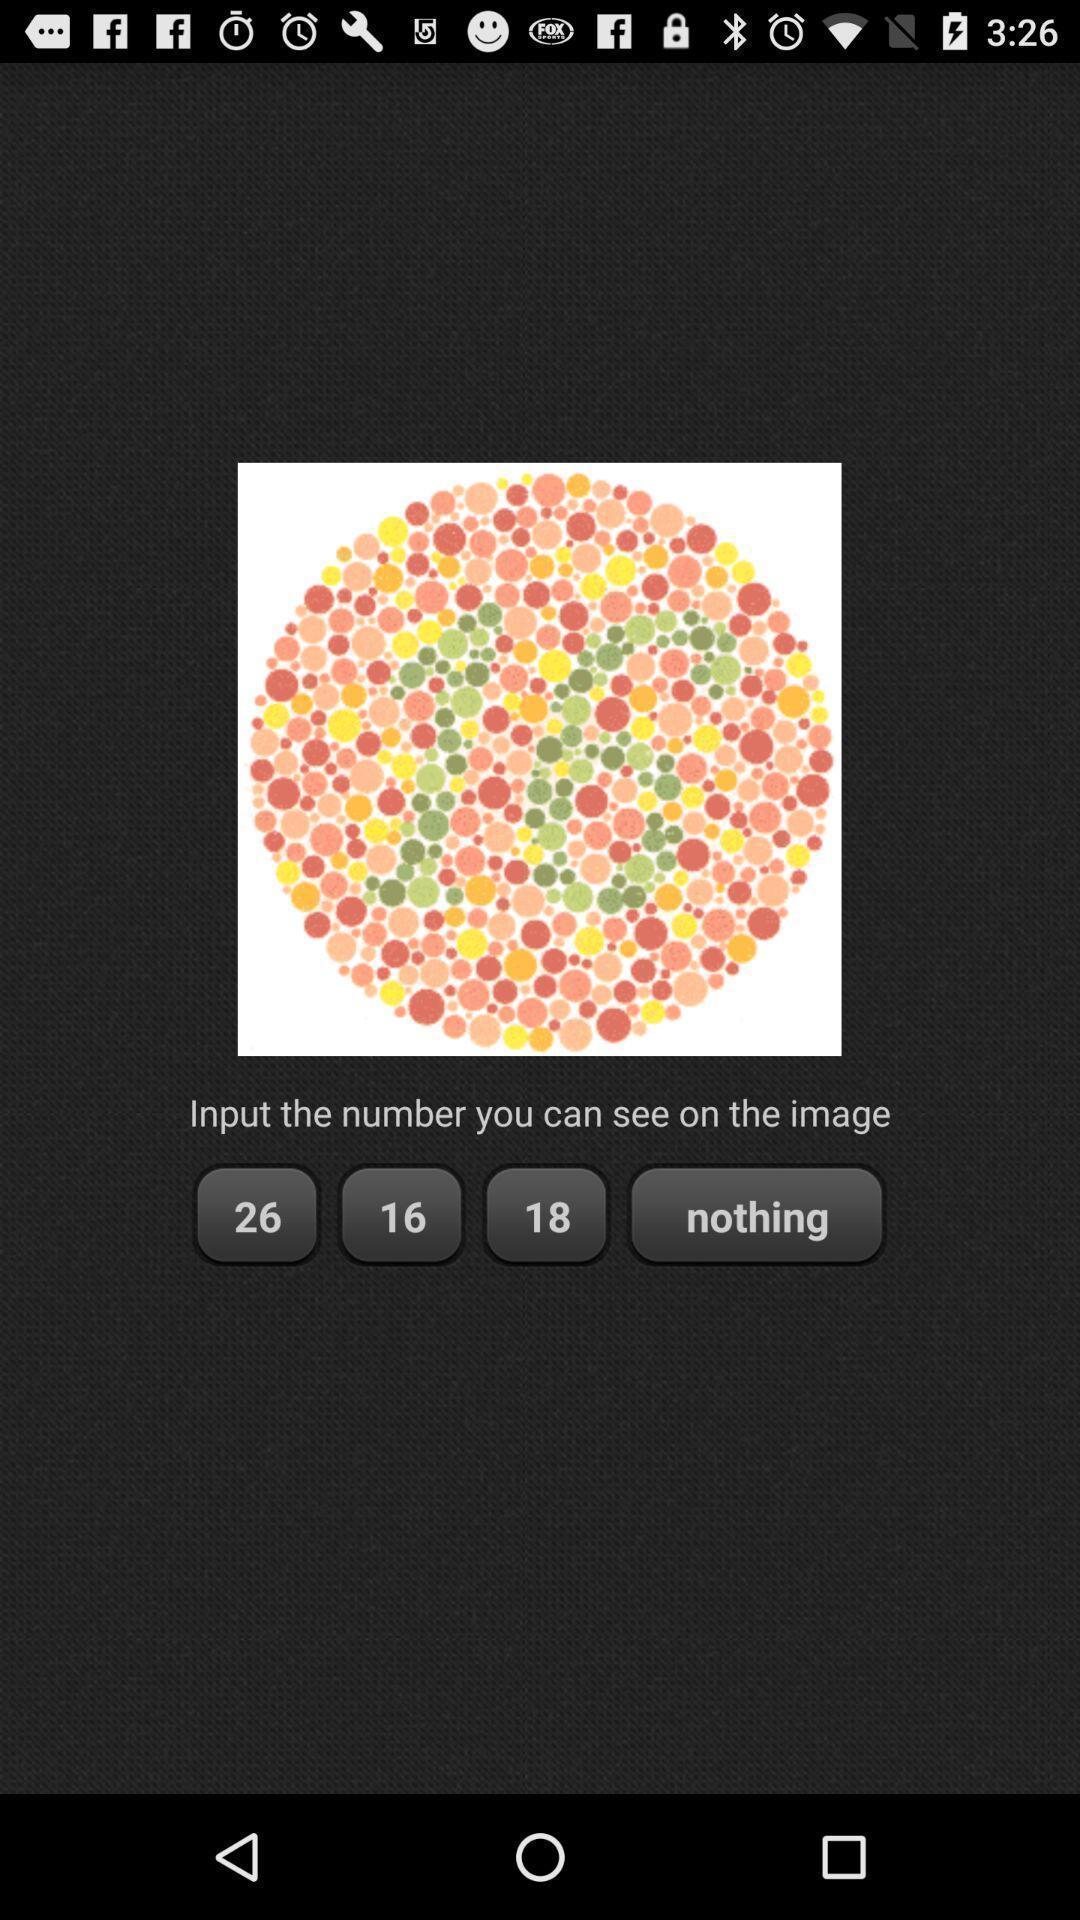Tell me about the visual elements in this screen capture. Screen shows about color blindness test. 